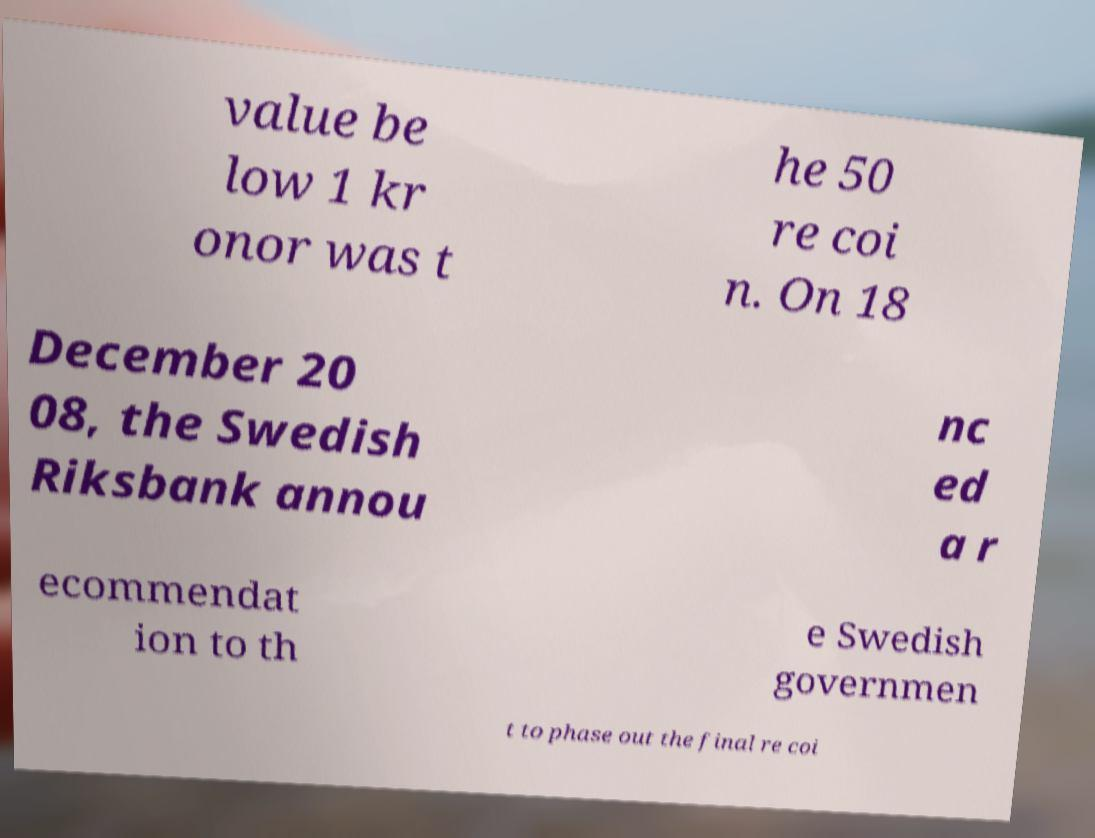Can you read and provide the text displayed in the image?This photo seems to have some interesting text. Can you extract and type it out for me? value be low 1 kr onor was t he 50 re coi n. On 18 December 20 08, the Swedish Riksbank annou nc ed a r ecommendat ion to th e Swedish governmen t to phase out the final re coi 